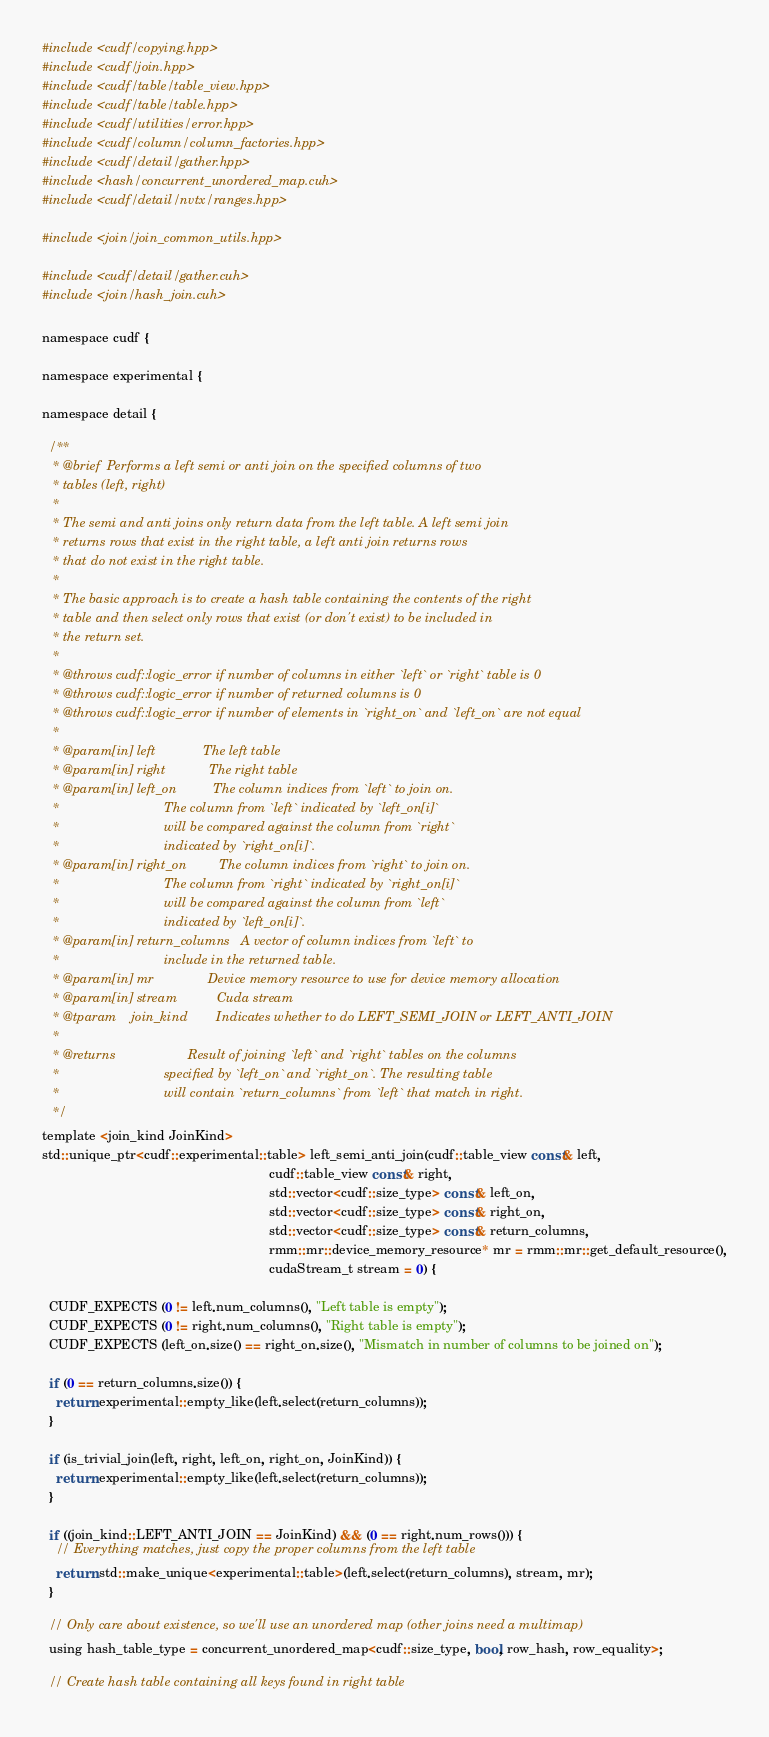<code> <loc_0><loc_0><loc_500><loc_500><_Cuda_>#include <cudf/copying.hpp>
#include <cudf/join.hpp>
#include <cudf/table/table_view.hpp>
#include <cudf/table/table.hpp>
#include <cudf/utilities/error.hpp>
#include <cudf/column/column_factories.hpp>
#include <cudf/detail/gather.hpp>
#include <hash/concurrent_unordered_map.cuh>
#include <cudf/detail/nvtx/ranges.hpp>

#include <join/join_common_utils.hpp>

#include <cudf/detail/gather.cuh>
#include <join/hash_join.cuh>

namespace cudf {

namespace experimental {

namespace detail {

  /** 
   * @brief  Performs a left semi or anti join on the specified columns of two 
   * tables (left, right)
   *
   * The semi and anti joins only return data from the left table. A left semi join
   * returns rows that exist in the right table, a left anti join returns rows
   * that do not exist in the right table.
   *
   * The basic approach is to create a hash table containing the contents of the right
   * table and then select only rows that exist (or don't exist) to be included in
   * the return set.
   *
   * @throws cudf::logic_error if number of columns in either `left` or `right` table is 0
   * @throws cudf::logic_error if number of returned columns is 0
   * @throws cudf::logic_error if number of elements in `right_on` and `left_on` are not equal
   *
   * @param[in] left             The left table
   * @param[in] right            The right table
   * @param[in] left_on          The column indices from `left` to join on.
   *                             The column from `left` indicated by `left_on[i]`
   *                             will be compared against the column from `right`
   *                             indicated by `right_on[i]`.
   * @param[in] right_on         The column indices from `right` to join on.
   *                             The column from `right` indicated by `right_on[i]`
   *                             will be compared against the column from `left`
   *                             indicated by `left_on[i]`.
   * @param[in] return_columns   A vector of column indices from `left` to
   *                             include in the returned table.
   * @param[in] mr               Device memory resource to use for device memory allocation
   * @param[in] stream           Cuda stream
   * @tparam    join_kind        Indicates whether to do LEFT_SEMI_JOIN or LEFT_ANTI_JOIN
   *
   * @returns                    Result of joining `left` and `right` tables on the columns
   *                             specified by `left_on` and `right_on`. The resulting table
   *                             will contain `return_columns` from `left` that match in right.
   */
template <join_kind JoinKind>
std::unique_ptr<cudf::experimental::table> left_semi_anti_join(cudf::table_view const& left,
                                                               cudf::table_view const& right,
                                                               std::vector<cudf::size_type> const& left_on,
                                                               std::vector<cudf::size_type> const& right_on,
                                                               std::vector<cudf::size_type> const& return_columns,
                                                               rmm::mr::device_memory_resource* mr = rmm::mr::get_default_resource(),
                                                               cudaStream_t stream = 0) {

  CUDF_EXPECTS (0 != left.num_columns(), "Left table is empty");
  CUDF_EXPECTS (0 != right.num_columns(), "Right table is empty");
  CUDF_EXPECTS (left_on.size() == right_on.size(), "Mismatch in number of columns to be joined on");

  if (0 == return_columns.size()) {
    return experimental::empty_like(left.select(return_columns));
  }

  if (is_trivial_join(left, right, left_on, right_on, JoinKind)) {
    return experimental::empty_like(left.select(return_columns));
  }

  if ((join_kind::LEFT_ANTI_JOIN == JoinKind) && (0 == right.num_rows())) {
    // Everything matches, just copy the proper columns from the left table
    return std::make_unique<experimental::table>(left.select(return_columns), stream, mr);
  }

  // Only care about existence, so we'll use an unordered map (other joins need a multimap)
  using hash_table_type = concurrent_unordered_map<cudf::size_type, bool, row_hash, row_equality>;

  // Create hash table containing all keys found in right table</code> 